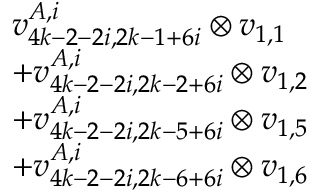Convert formula to latex. <formula><loc_0><loc_0><loc_500><loc_500>\begin{array} { r l } & { v _ { 4 k - 2 - 2 i , 2 k - 1 + 6 i } ^ { A , i } \otimes v _ { 1 , 1 } } \\ & { + v _ { 4 k - 2 - 2 i , 2 k - 2 + 6 i } ^ { A , i } \otimes v _ { 1 , 2 } } \\ & { + v _ { 4 k - 2 - 2 i , 2 k - 5 + 6 i } ^ { A , i } \otimes v _ { 1 , 5 } } \\ & { + v _ { 4 k - 2 - 2 i , 2 k - 6 + 6 i } ^ { A , i } \otimes v _ { 1 , 6 } } \end{array}</formula> 